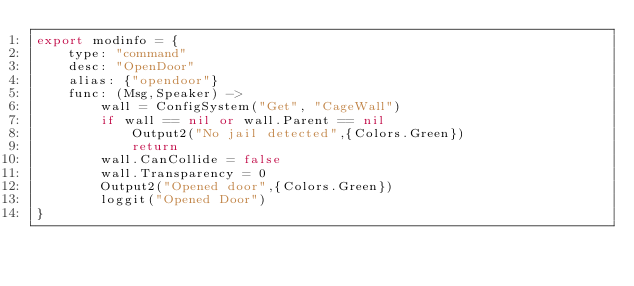<code> <loc_0><loc_0><loc_500><loc_500><_MoonScript_>export modinfo = {
	type: "command"
	desc: "OpenDoor"
	alias: {"opendoor"}
	func: (Msg,Speaker) ->
		wall = ConfigSystem("Get", "CageWall")
		if wall == nil or wall.Parent == nil 
			Output2("No jail detected",{Colors.Green}) 
			return
		wall.CanCollide = false
		wall.Transparency = 0
		Output2("Opened door",{Colors.Green})
		loggit("Opened Door")
}</code> 